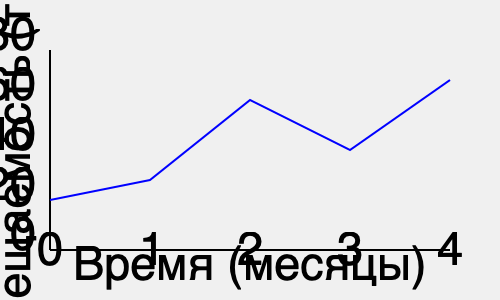На графике показана посещаемость веб-сайта за 4 месяца. В каком месяце наблюдался наибольший рост трафика по сравнению с предыдущим месяцем? Для определения месяца с наибольшим ростом трафика нужно:

1. Проанализировать изменение посещаемости между каждой парой последовательных месяцев:
   - Между 0 и 1 месяцем: небольшое увеличение
   - Между 1 и 2 месяцем: значительное увеличение
   - Между 2 и 3 месяцем: уменьшение
   - Между 3 и 4 месяцем: увеличение

2. Сравнить величину изменений:
   - Наибольший рост наблюдается между 1 и 2 месяцем

3. Определить соответствующий месяц:
   - Рост происходит во втором месяце по отношению к первому

Таким образом, наибольший рост трафика наблюдался во втором месяце.
Answer: 2-й месяц 